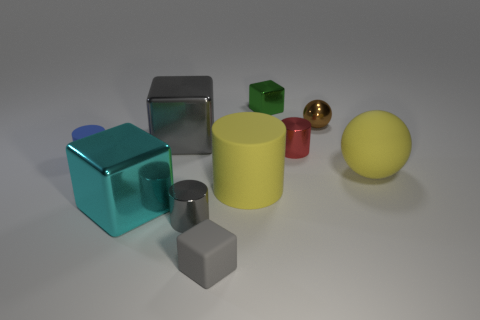Is the color of the large sphere the same as the big cylinder?
Provide a succinct answer. Yes. What shape is the yellow matte object that is the same size as the yellow matte sphere?
Your answer should be very brief. Cylinder. What is the color of the other large thing that is the same shape as the brown shiny thing?
Your answer should be very brief. Yellow. What number of objects are tiny purple matte cubes or tiny red metallic cylinders?
Keep it short and to the point. 1. There is a yellow matte thing on the left side of the brown sphere; is its shape the same as the gray shiny object that is in front of the cyan object?
Keep it short and to the point. Yes. What shape is the large yellow rubber thing that is to the right of the red cylinder?
Your response must be concise. Sphere. Is the number of tiny objects that are on the right side of the small brown ball the same as the number of small blue matte cylinders on the right side of the small rubber block?
Offer a terse response. Yes. How many objects are either small blue rubber cylinders or big things that are on the right side of the large gray shiny thing?
Offer a very short reply. 3. What is the shape of the large thing that is to the right of the gray rubber object and behind the big cylinder?
Your answer should be compact. Sphere. What material is the small cylinder left of the gray block on the left side of the rubber cube made of?
Give a very brief answer. Rubber. 